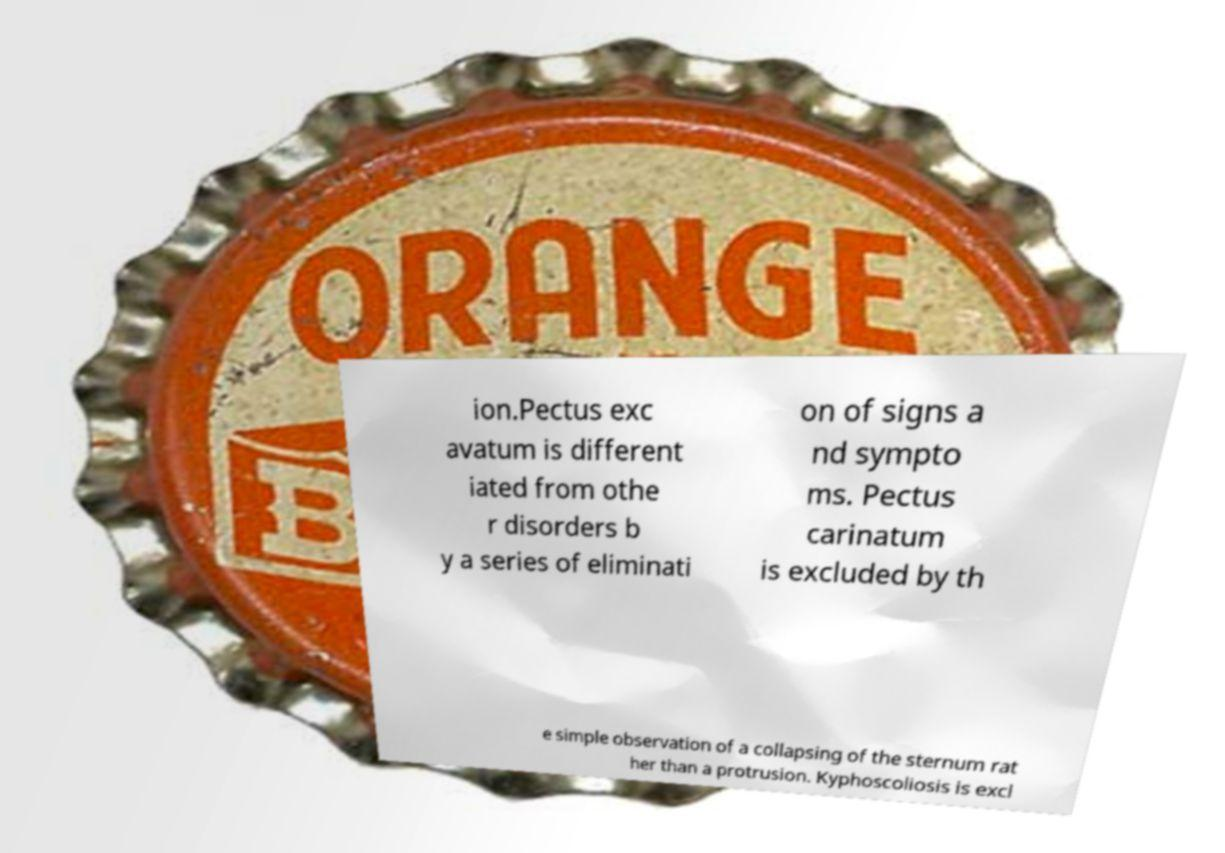Please read and relay the text visible in this image. What does it say? ion.Pectus exc avatum is different iated from othe r disorders b y a series of eliminati on of signs a nd sympto ms. Pectus carinatum is excluded by th e simple observation of a collapsing of the sternum rat her than a protrusion. Kyphoscoliosis is excl 